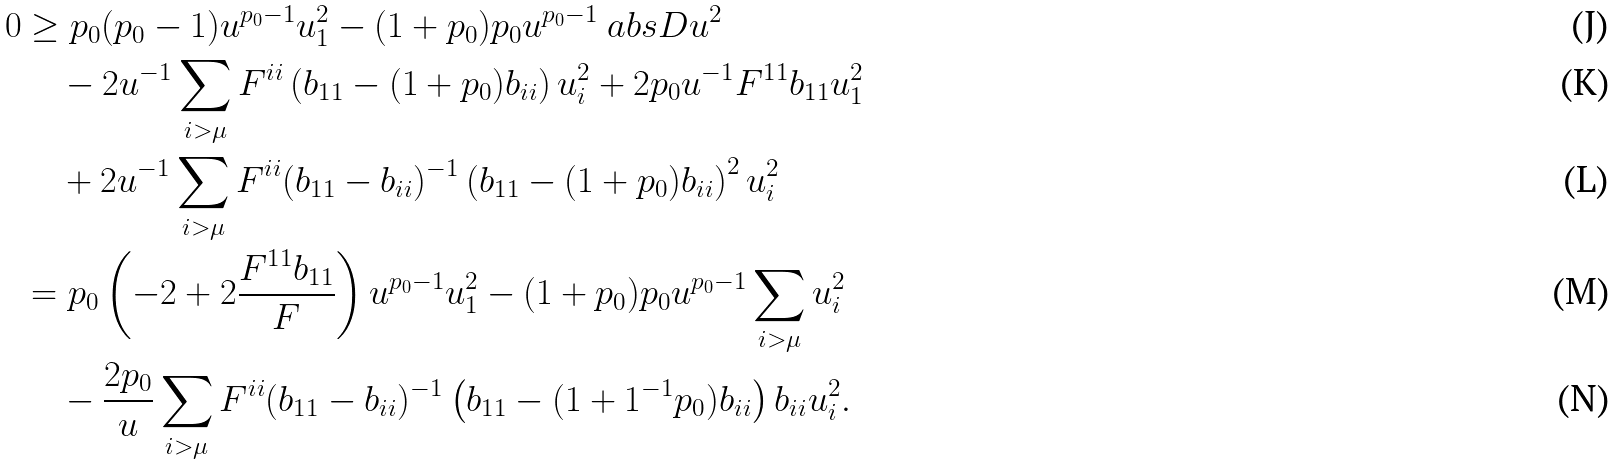Convert formula to latex. <formula><loc_0><loc_0><loc_500><loc_500>0 & \geq p _ { 0 } ( p _ { 0 } - 1 ) u ^ { p _ { 0 } - 1 } u _ { 1 } ^ { 2 } - ( 1 + p _ { 0 } ) p _ { 0 } u ^ { p _ { 0 } - 1 } \ a b s { D u } ^ { 2 } \\ & \quad - 2 u ^ { - 1 } \sum _ { i > \mu } F ^ { i i } \left ( b _ { 1 1 } - ( 1 + p _ { 0 } ) b _ { i i } \right ) u _ { i } ^ { 2 } + 2 p _ { 0 } u ^ { - 1 } F ^ { 1 1 } b _ { 1 1 } u _ { 1 } ^ { 2 } \\ & \quad + 2 u ^ { - 1 } \sum _ { i > \mu } F ^ { i i } ( b _ { 1 1 } - b _ { i i } ) ^ { - 1 } \left ( b _ { 1 1 } - ( 1 + p _ { 0 } ) b _ { i i } \right ) ^ { 2 } u _ { i } ^ { 2 } \\ & = p _ { 0 } \left ( - 2 + 2 \frac { F ^ { 1 1 } b _ { 1 1 } } { F } \right ) u ^ { p _ { 0 } - 1 } u _ { 1 } ^ { 2 } - ( 1 + p _ { 0 } ) p _ { 0 } u ^ { p _ { 0 } - 1 } \sum _ { i > \mu } u _ { i } ^ { 2 } \\ & \quad - \frac { 2 p _ { 0 } } { u } \sum _ { i > \mu } F ^ { i i } ( b _ { 1 1 } - b _ { i i } ) ^ { - 1 } \left ( b _ { 1 1 } - ( 1 + 1 ^ { - 1 } p _ { 0 } ) b _ { i i } \right ) b _ { i i } u _ { i } ^ { 2 } .</formula> 